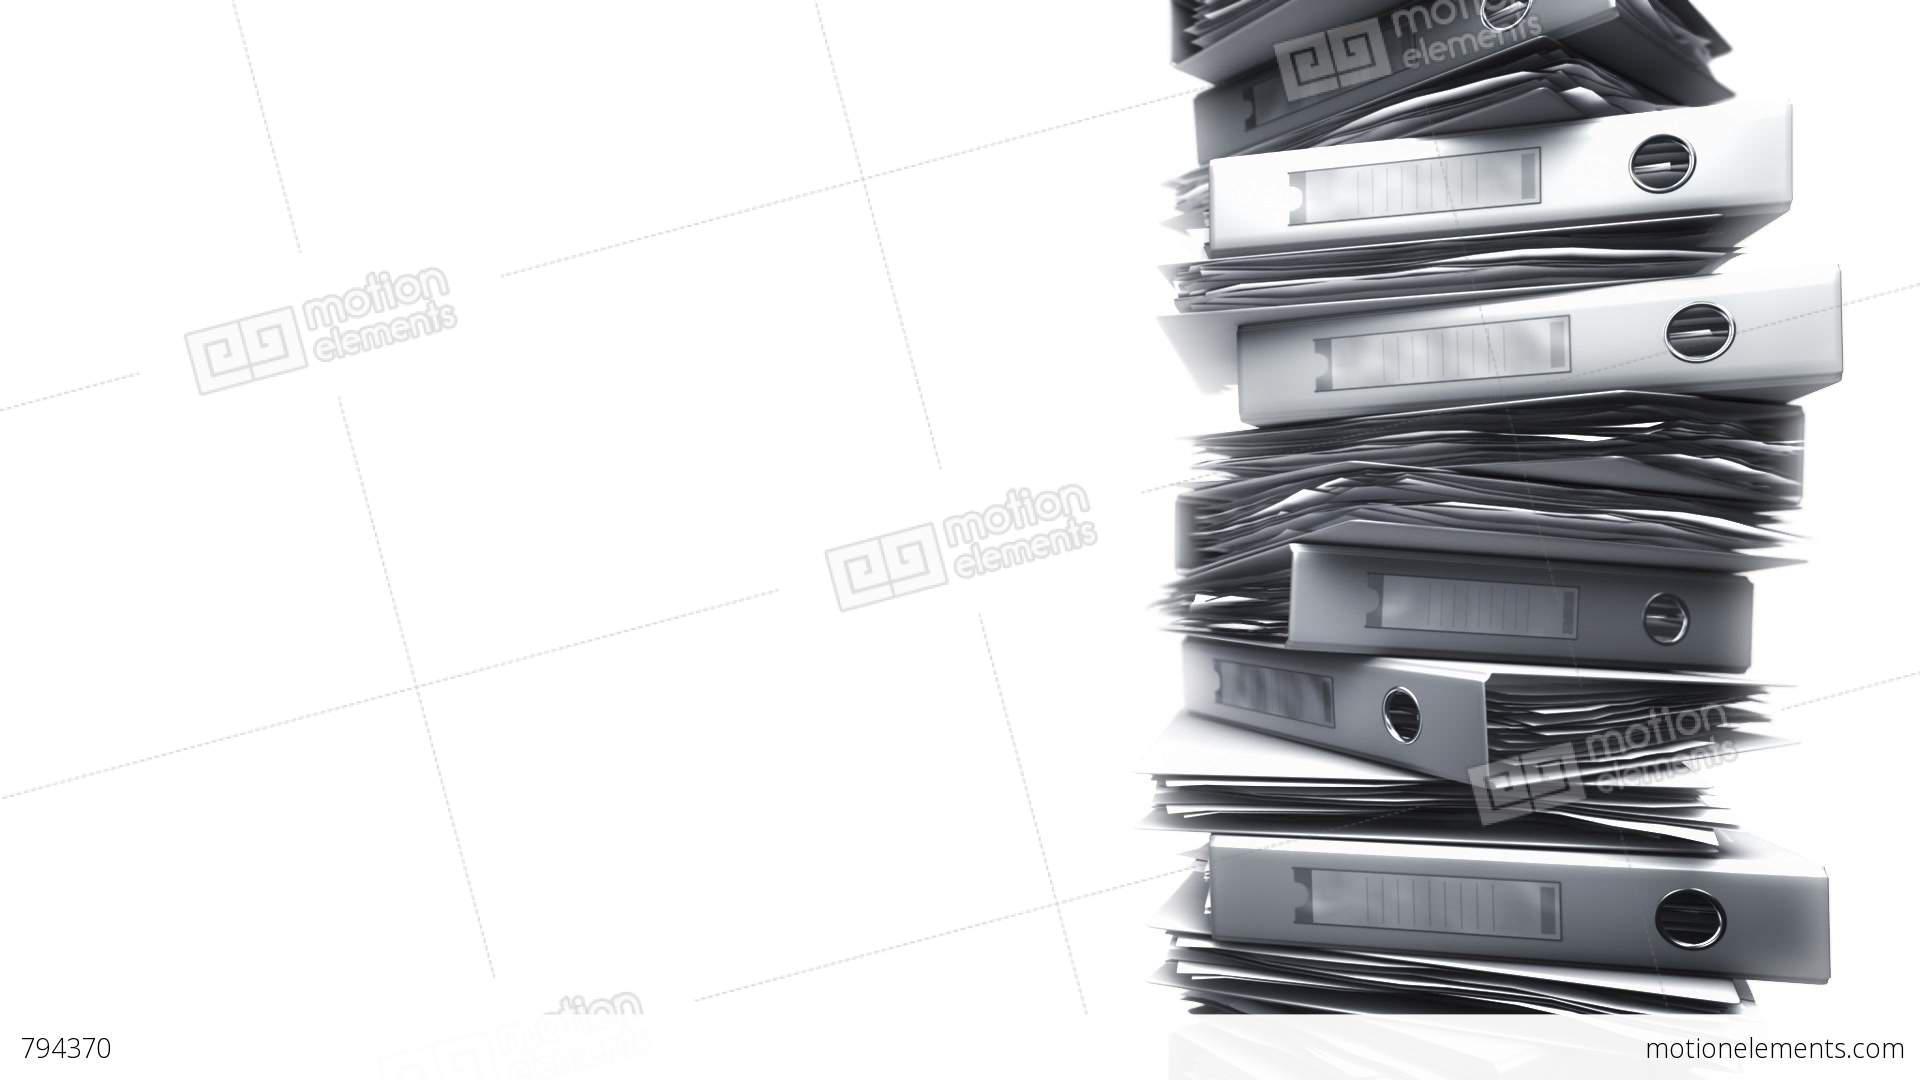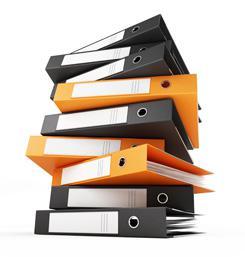The first image is the image on the left, the second image is the image on the right. Examine the images to the left and right. Is the description "An image contains no more than five binders, which are stacked alternately, front to back." accurate? Answer yes or no. No. 